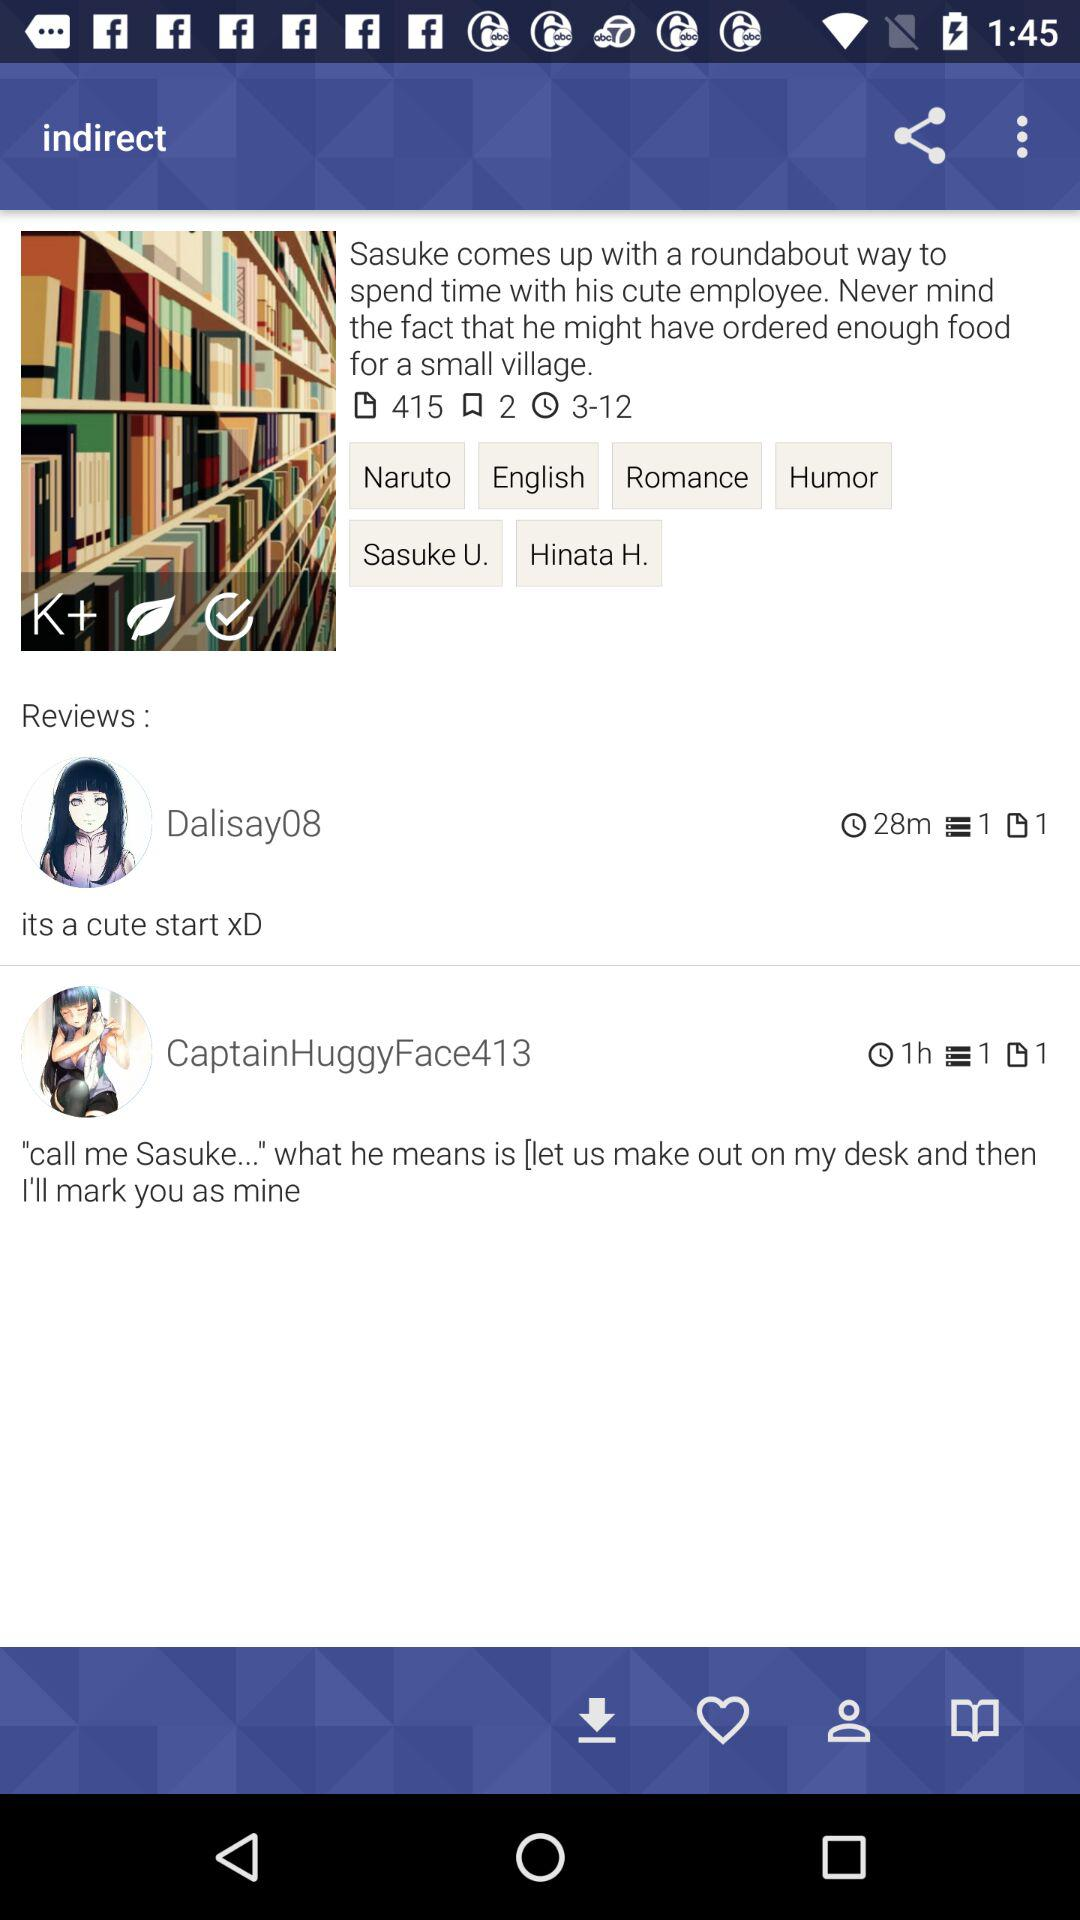How many reviews are there on this page?
Answer the question using a single word or phrase. 2 